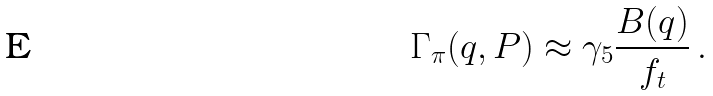Convert formula to latex. <formula><loc_0><loc_0><loc_500><loc_500>\Gamma _ { \pi } ( q , P ) \approx \gamma _ { 5 } \frac { B ( q ) } { f _ { t } } \, .</formula> 